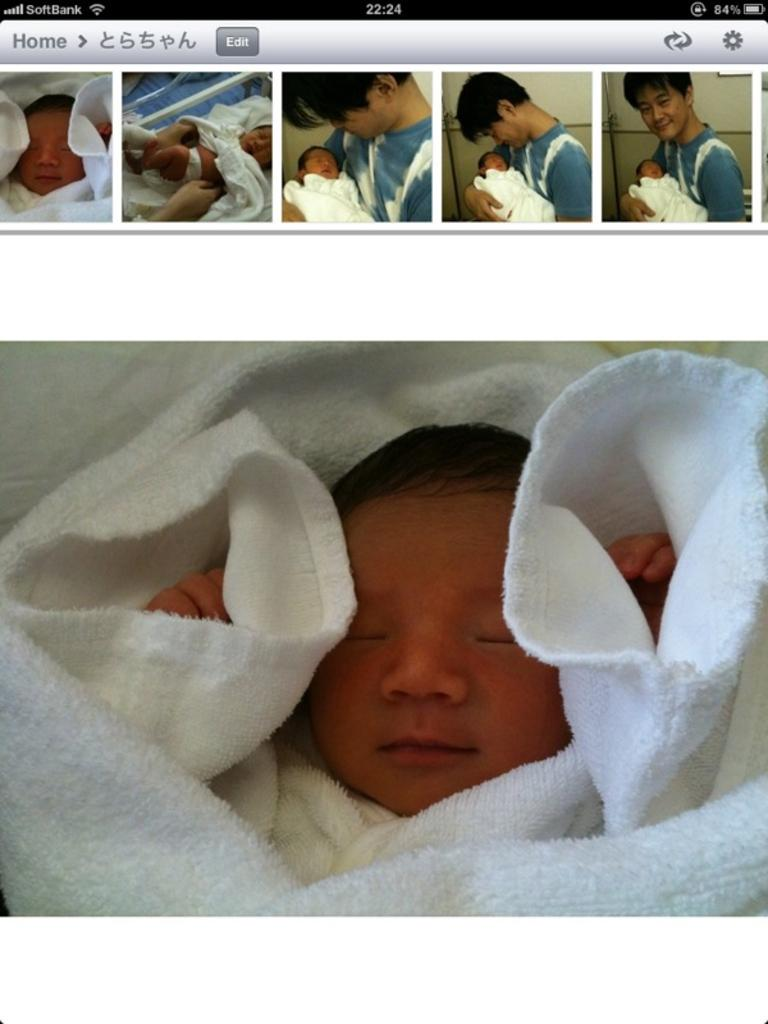What is the main subject of the image? The main subject of the image is a screenshot of a mobile. What else can be seen in the image besides the mobile screenshot? There is a small baby in the image. What is the baby doing in the image? The baby is sleeping. How is the baby dressed or covered in the image? The baby is wrapped in white cloth. What type of boat can be seen in the image? There is no boat present in the image. What do you believe the baby is dreaming about in the image? We cannot determine what the baby is dreaming about from the image, as it only shows the baby sleeping and wrapped in white cloth. 